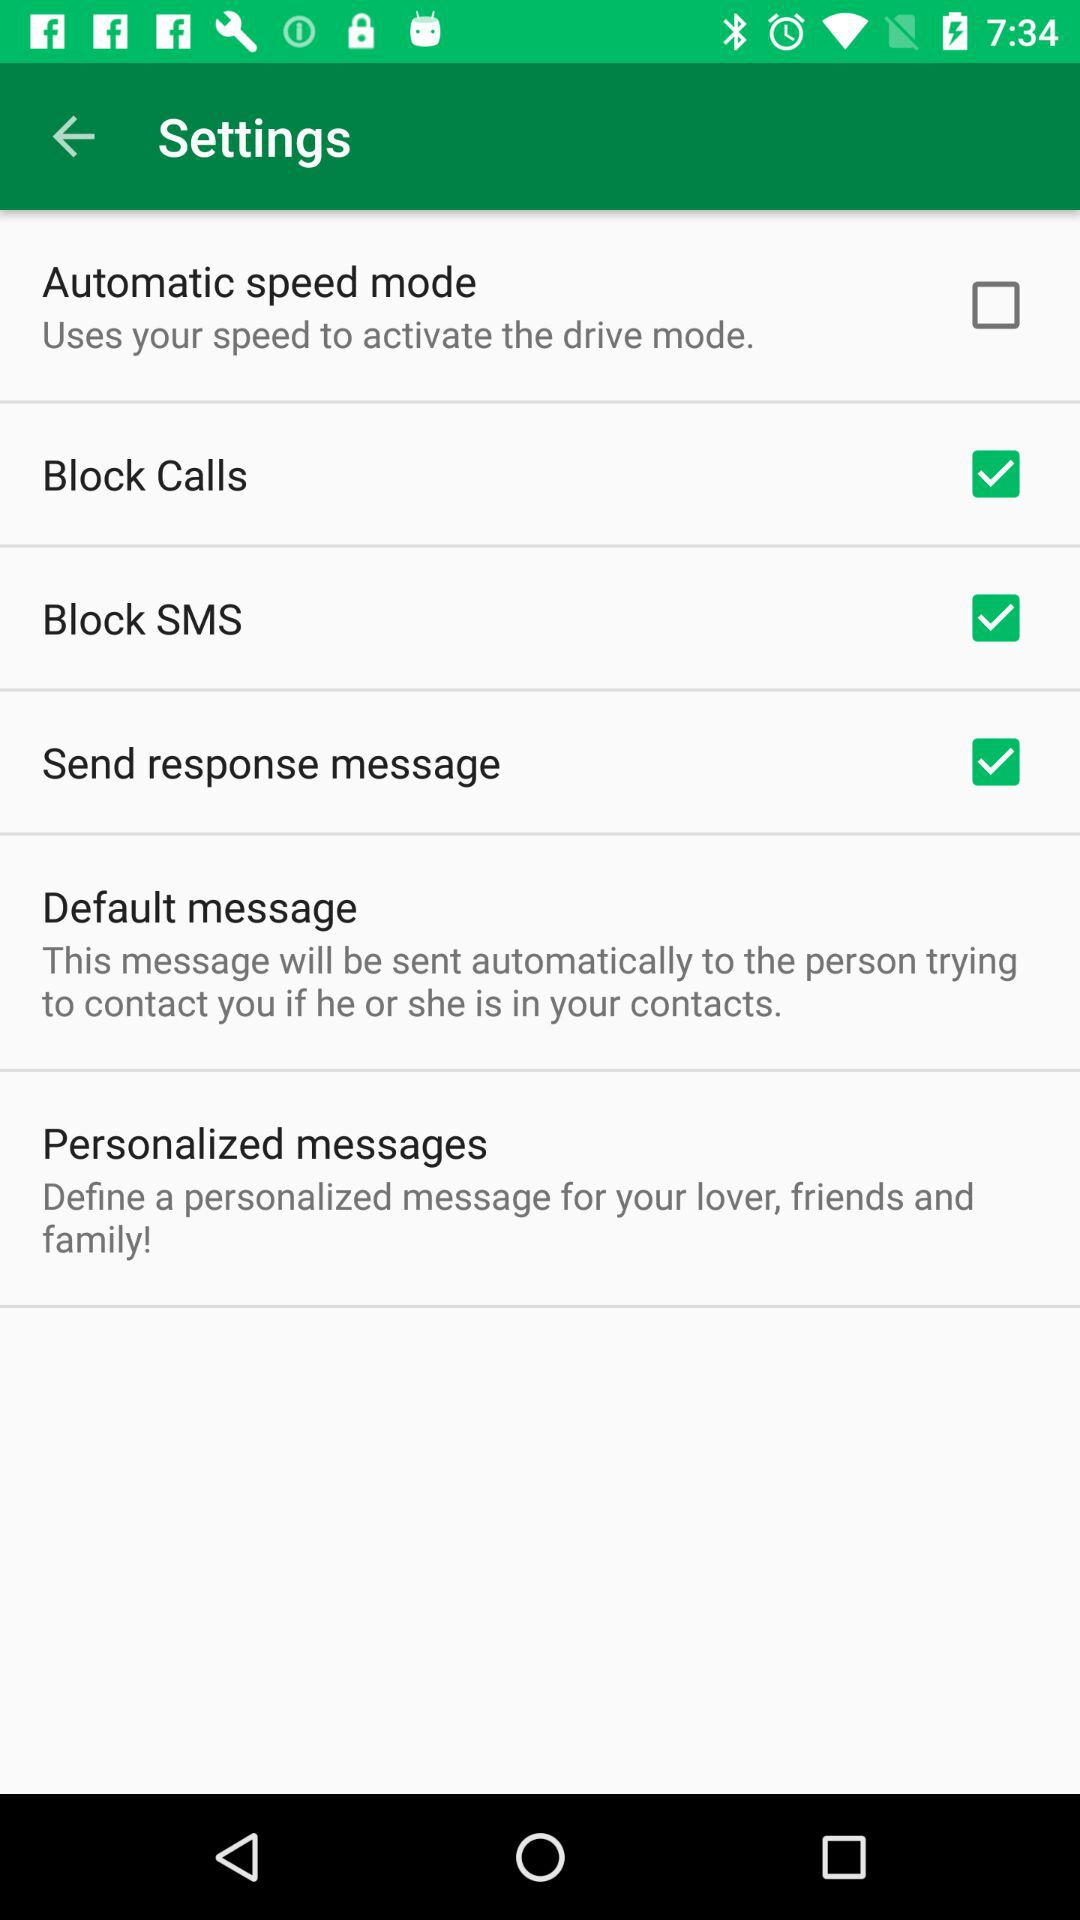What is the status of block calls? The status is on. 